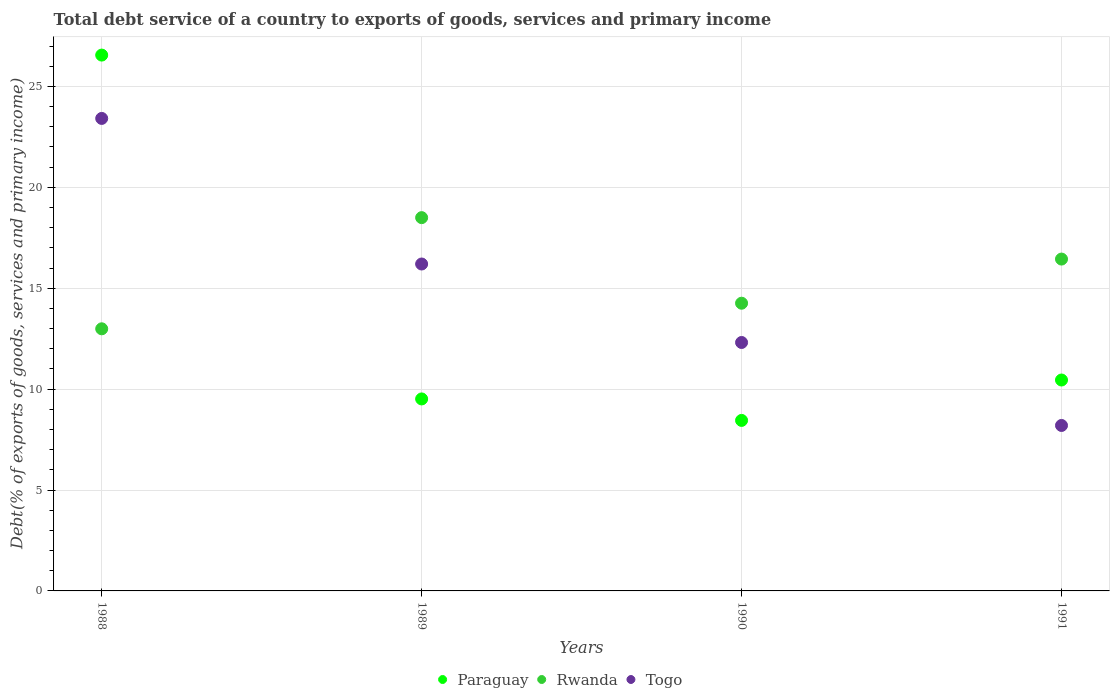How many different coloured dotlines are there?
Provide a succinct answer. 3. Is the number of dotlines equal to the number of legend labels?
Your response must be concise. Yes. What is the total debt service in Togo in 1990?
Give a very brief answer. 12.31. Across all years, what is the maximum total debt service in Togo?
Give a very brief answer. 23.42. Across all years, what is the minimum total debt service in Rwanda?
Provide a succinct answer. 12.99. What is the total total debt service in Rwanda in the graph?
Offer a very short reply. 62.19. What is the difference between the total debt service in Paraguay in 1990 and that in 1991?
Offer a very short reply. -2. What is the difference between the total debt service in Rwanda in 1991 and the total debt service in Togo in 1990?
Your answer should be compact. 4.13. What is the average total debt service in Rwanda per year?
Make the answer very short. 15.55. In the year 1988, what is the difference between the total debt service in Rwanda and total debt service in Togo?
Your answer should be very brief. -10.43. What is the ratio of the total debt service in Togo in 1988 to that in 1989?
Keep it short and to the point. 1.45. What is the difference between the highest and the second highest total debt service in Paraguay?
Make the answer very short. 16.1. What is the difference between the highest and the lowest total debt service in Paraguay?
Your answer should be very brief. 18.1. Is it the case that in every year, the sum of the total debt service in Paraguay and total debt service in Togo  is greater than the total debt service in Rwanda?
Give a very brief answer. Yes. How many dotlines are there?
Ensure brevity in your answer.  3. How many years are there in the graph?
Give a very brief answer. 4. What is the difference between two consecutive major ticks on the Y-axis?
Your answer should be compact. 5. Are the values on the major ticks of Y-axis written in scientific E-notation?
Ensure brevity in your answer.  No. How many legend labels are there?
Offer a terse response. 3. What is the title of the graph?
Give a very brief answer. Total debt service of a country to exports of goods, services and primary income. Does "OECD members" appear as one of the legend labels in the graph?
Your response must be concise. No. What is the label or title of the Y-axis?
Provide a short and direct response. Debt(% of exports of goods, services and primary income). What is the Debt(% of exports of goods, services and primary income) in Paraguay in 1988?
Give a very brief answer. 26.55. What is the Debt(% of exports of goods, services and primary income) of Rwanda in 1988?
Give a very brief answer. 12.99. What is the Debt(% of exports of goods, services and primary income) in Togo in 1988?
Offer a very short reply. 23.42. What is the Debt(% of exports of goods, services and primary income) of Paraguay in 1989?
Your answer should be very brief. 9.51. What is the Debt(% of exports of goods, services and primary income) in Rwanda in 1989?
Provide a short and direct response. 18.5. What is the Debt(% of exports of goods, services and primary income) in Togo in 1989?
Keep it short and to the point. 16.2. What is the Debt(% of exports of goods, services and primary income) of Paraguay in 1990?
Your answer should be very brief. 8.45. What is the Debt(% of exports of goods, services and primary income) of Rwanda in 1990?
Your answer should be compact. 14.26. What is the Debt(% of exports of goods, services and primary income) of Togo in 1990?
Your answer should be very brief. 12.31. What is the Debt(% of exports of goods, services and primary income) of Paraguay in 1991?
Your response must be concise. 10.45. What is the Debt(% of exports of goods, services and primary income) in Rwanda in 1991?
Provide a succinct answer. 16.45. What is the Debt(% of exports of goods, services and primary income) in Togo in 1991?
Ensure brevity in your answer.  8.2. Across all years, what is the maximum Debt(% of exports of goods, services and primary income) of Paraguay?
Provide a succinct answer. 26.55. Across all years, what is the maximum Debt(% of exports of goods, services and primary income) of Rwanda?
Provide a succinct answer. 18.5. Across all years, what is the maximum Debt(% of exports of goods, services and primary income) in Togo?
Your answer should be very brief. 23.42. Across all years, what is the minimum Debt(% of exports of goods, services and primary income) of Paraguay?
Provide a short and direct response. 8.45. Across all years, what is the minimum Debt(% of exports of goods, services and primary income) in Rwanda?
Offer a very short reply. 12.99. Across all years, what is the minimum Debt(% of exports of goods, services and primary income) in Togo?
Your answer should be compact. 8.2. What is the total Debt(% of exports of goods, services and primary income) in Paraguay in the graph?
Keep it short and to the point. 54.97. What is the total Debt(% of exports of goods, services and primary income) in Rwanda in the graph?
Offer a very short reply. 62.19. What is the total Debt(% of exports of goods, services and primary income) in Togo in the graph?
Your response must be concise. 60.13. What is the difference between the Debt(% of exports of goods, services and primary income) of Paraguay in 1988 and that in 1989?
Ensure brevity in your answer.  17.04. What is the difference between the Debt(% of exports of goods, services and primary income) of Rwanda in 1988 and that in 1989?
Your response must be concise. -5.51. What is the difference between the Debt(% of exports of goods, services and primary income) in Togo in 1988 and that in 1989?
Offer a terse response. 7.21. What is the difference between the Debt(% of exports of goods, services and primary income) of Paraguay in 1988 and that in 1990?
Your answer should be compact. 18.1. What is the difference between the Debt(% of exports of goods, services and primary income) in Rwanda in 1988 and that in 1990?
Your answer should be compact. -1.27. What is the difference between the Debt(% of exports of goods, services and primary income) of Togo in 1988 and that in 1990?
Offer a terse response. 11.1. What is the difference between the Debt(% of exports of goods, services and primary income) of Paraguay in 1988 and that in 1991?
Provide a succinct answer. 16.1. What is the difference between the Debt(% of exports of goods, services and primary income) in Rwanda in 1988 and that in 1991?
Ensure brevity in your answer.  -3.46. What is the difference between the Debt(% of exports of goods, services and primary income) of Togo in 1988 and that in 1991?
Your response must be concise. 15.22. What is the difference between the Debt(% of exports of goods, services and primary income) of Paraguay in 1989 and that in 1990?
Your answer should be very brief. 1.06. What is the difference between the Debt(% of exports of goods, services and primary income) in Rwanda in 1989 and that in 1990?
Make the answer very short. 4.24. What is the difference between the Debt(% of exports of goods, services and primary income) in Togo in 1989 and that in 1990?
Give a very brief answer. 3.89. What is the difference between the Debt(% of exports of goods, services and primary income) in Paraguay in 1989 and that in 1991?
Keep it short and to the point. -0.94. What is the difference between the Debt(% of exports of goods, services and primary income) in Rwanda in 1989 and that in 1991?
Your response must be concise. 2.05. What is the difference between the Debt(% of exports of goods, services and primary income) in Togo in 1989 and that in 1991?
Provide a succinct answer. 8. What is the difference between the Debt(% of exports of goods, services and primary income) in Paraguay in 1990 and that in 1991?
Keep it short and to the point. -2. What is the difference between the Debt(% of exports of goods, services and primary income) of Rwanda in 1990 and that in 1991?
Your answer should be very brief. -2.19. What is the difference between the Debt(% of exports of goods, services and primary income) in Togo in 1990 and that in 1991?
Make the answer very short. 4.11. What is the difference between the Debt(% of exports of goods, services and primary income) of Paraguay in 1988 and the Debt(% of exports of goods, services and primary income) of Rwanda in 1989?
Your answer should be very brief. 8.06. What is the difference between the Debt(% of exports of goods, services and primary income) in Paraguay in 1988 and the Debt(% of exports of goods, services and primary income) in Togo in 1989?
Your response must be concise. 10.35. What is the difference between the Debt(% of exports of goods, services and primary income) in Rwanda in 1988 and the Debt(% of exports of goods, services and primary income) in Togo in 1989?
Your response must be concise. -3.21. What is the difference between the Debt(% of exports of goods, services and primary income) of Paraguay in 1988 and the Debt(% of exports of goods, services and primary income) of Rwanda in 1990?
Your answer should be compact. 12.3. What is the difference between the Debt(% of exports of goods, services and primary income) in Paraguay in 1988 and the Debt(% of exports of goods, services and primary income) in Togo in 1990?
Provide a short and direct response. 14.24. What is the difference between the Debt(% of exports of goods, services and primary income) in Rwanda in 1988 and the Debt(% of exports of goods, services and primary income) in Togo in 1990?
Provide a short and direct response. 0.68. What is the difference between the Debt(% of exports of goods, services and primary income) of Paraguay in 1988 and the Debt(% of exports of goods, services and primary income) of Rwanda in 1991?
Give a very brief answer. 10.11. What is the difference between the Debt(% of exports of goods, services and primary income) in Paraguay in 1988 and the Debt(% of exports of goods, services and primary income) in Togo in 1991?
Offer a terse response. 18.35. What is the difference between the Debt(% of exports of goods, services and primary income) of Rwanda in 1988 and the Debt(% of exports of goods, services and primary income) of Togo in 1991?
Ensure brevity in your answer.  4.79. What is the difference between the Debt(% of exports of goods, services and primary income) of Paraguay in 1989 and the Debt(% of exports of goods, services and primary income) of Rwanda in 1990?
Keep it short and to the point. -4.74. What is the difference between the Debt(% of exports of goods, services and primary income) of Paraguay in 1989 and the Debt(% of exports of goods, services and primary income) of Togo in 1990?
Provide a succinct answer. -2.8. What is the difference between the Debt(% of exports of goods, services and primary income) of Rwanda in 1989 and the Debt(% of exports of goods, services and primary income) of Togo in 1990?
Make the answer very short. 6.19. What is the difference between the Debt(% of exports of goods, services and primary income) of Paraguay in 1989 and the Debt(% of exports of goods, services and primary income) of Rwanda in 1991?
Give a very brief answer. -6.93. What is the difference between the Debt(% of exports of goods, services and primary income) of Paraguay in 1989 and the Debt(% of exports of goods, services and primary income) of Togo in 1991?
Keep it short and to the point. 1.31. What is the difference between the Debt(% of exports of goods, services and primary income) of Rwanda in 1989 and the Debt(% of exports of goods, services and primary income) of Togo in 1991?
Ensure brevity in your answer.  10.3. What is the difference between the Debt(% of exports of goods, services and primary income) in Paraguay in 1990 and the Debt(% of exports of goods, services and primary income) in Rwanda in 1991?
Give a very brief answer. -8. What is the difference between the Debt(% of exports of goods, services and primary income) in Paraguay in 1990 and the Debt(% of exports of goods, services and primary income) in Togo in 1991?
Offer a terse response. 0.25. What is the difference between the Debt(% of exports of goods, services and primary income) in Rwanda in 1990 and the Debt(% of exports of goods, services and primary income) in Togo in 1991?
Give a very brief answer. 6.06. What is the average Debt(% of exports of goods, services and primary income) in Paraguay per year?
Provide a succinct answer. 13.74. What is the average Debt(% of exports of goods, services and primary income) in Rwanda per year?
Provide a short and direct response. 15.55. What is the average Debt(% of exports of goods, services and primary income) of Togo per year?
Offer a terse response. 15.03. In the year 1988, what is the difference between the Debt(% of exports of goods, services and primary income) of Paraguay and Debt(% of exports of goods, services and primary income) of Rwanda?
Make the answer very short. 13.56. In the year 1988, what is the difference between the Debt(% of exports of goods, services and primary income) of Paraguay and Debt(% of exports of goods, services and primary income) of Togo?
Make the answer very short. 3.14. In the year 1988, what is the difference between the Debt(% of exports of goods, services and primary income) of Rwanda and Debt(% of exports of goods, services and primary income) of Togo?
Ensure brevity in your answer.  -10.43. In the year 1989, what is the difference between the Debt(% of exports of goods, services and primary income) of Paraguay and Debt(% of exports of goods, services and primary income) of Rwanda?
Offer a terse response. -8.98. In the year 1989, what is the difference between the Debt(% of exports of goods, services and primary income) of Paraguay and Debt(% of exports of goods, services and primary income) of Togo?
Offer a terse response. -6.69. In the year 1989, what is the difference between the Debt(% of exports of goods, services and primary income) in Rwanda and Debt(% of exports of goods, services and primary income) in Togo?
Ensure brevity in your answer.  2.3. In the year 1990, what is the difference between the Debt(% of exports of goods, services and primary income) of Paraguay and Debt(% of exports of goods, services and primary income) of Rwanda?
Ensure brevity in your answer.  -5.81. In the year 1990, what is the difference between the Debt(% of exports of goods, services and primary income) in Paraguay and Debt(% of exports of goods, services and primary income) in Togo?
Give a very brief answer. -3.86. In the year 1990, what is the difference between the Debt(% of exports of goods, services and primary income) of Rwanda and Debt(% of exports of goods, services and primary income) of Togo?
Your answer should be compact. 1.95. In the year 1991, what is the difference between the Debt(% of exports of goods, services and primary income) of Paraguay and Debt(% of exports of goods, services and primary income) of Rwanda?
Make the answer very short. -5.99. In the year 1991, what is the difference between the Debt(% of exports of goods, services and primary income) in Paraguay and Debt(% of exports of goods, services and primary income) in Togo?
Provide a succinct answer. 2.25. In the year 1991, what is the difference between the Debt(% of exports of goods, services and primary income) of Rwanda and Debt(% of exports of goods, services and primary income) of Togo?
Your answer should be compact. 8.25. What is the ratio of the Debt(% of exports of goods, services and primary income) of Paraguay in 1988 to that in 1989?
Keep it short and to the point. 2.79. What is the ratio of the Debt(% of exports of goods, services and primary income) in Rwanda in 1988 to that in 1989?
Ensure brevity in your answer.  0.7. What is the ratio of the Debt(% of exports of goods, services and primary income) in Togo in 1988 to that in 1989?
Ensure brevity in your answer.  1.45. What is the ratio of the Debt(% of exports of goods, services and primary income) of Paraguay in 1988 to that in 1990?
Ensure brevity in your answer.  3.14. What is the ratio of the Debt(% of exports of goods, services and primary income) of Rwanda in 1988 to that in 1990?
Provide a short and direct response. 0.91. What is the ratio of the Debt(% of exports of goods, services and primary income) in Togo in 1988 to that in 1990?
Make the answer very short. 1.9. What is the ratio of the Debt(% of exports of goods, services and primary income) of Paraguay in 1988 to that in 1991?
Give a very brief answer. 2.54. What is the ratio of the Debt(% of exports of goods, services and primary income) of Rwanda in 1988 to that in 1991?
Offer a terse response. 0.79. What is the ratio of the Debt(% of exports of goods, services and primary income) in Togo in 1988 to that in 1991?
Provide a succinct answer. 2.86. What is the ratio of the Debt(% of exports of goods, services and primary income) of Paraguay in 1989 to that in 1990?
Offer a terse response. 1.13. What is the ratio of the Debt(% of exports of goods, services and primary income) in Rwanda in 1989 to that in 1990?
Provide a succinct answer. 1.3. What is the ratio of the Debt(% of exports of goods, services and primary income) in Togo in 1989 to that in 1990?
Offer a very short reply. 1.32. What is the ratio of the Debt(% of exports of goods, services and primary income) of Paraguay in 1989 to that in 1991?
Offer a terse response. 0.91. What is the ratio of the Debt(% of exports of goods, services and primary income) in Rwanda in 1989 to that in 1991?
Keep it short and to the point. 1.12. What is the ratio of the Debt(% of exports of goods, services and primary income) in Togo in 1989 to that in 1991?
Give a very brief answer. 1.98. What is the ratio of the Debt(% of exports of goods, services and primary income) in Paraguay in 1990 to that in 1991?
Offer a terse response. 0.81. What is the ratio of the Debt(% of exports of goods, services and primary income) of Rwanda in 1990 to that in 1991?
Offer a terse response. 0.87. What is the ratio of the Debt(% of exports of goods, services and primary income) of Togo in 1990 to that in 1991?
Your response must be concise. 1.5. What is the difference between the highest and the second highest Debt(% of exports of goods, services and primary income) of Paraguay?
Provide a succinct answer. 16.1. What is the difference between the highest and the second highest Debt(% of exports of goods, services and primary income) of Rwanda?
Your answer should be compact. 2.05. What is the difference between the highest and the second highest Debt(% of exports of goods, services and primary income) in Togo?
Make the answer very short. 7.21. What is the difference between the highest and the lowest Debt(% of exports of goods, services and primary income) of Paraguay?
Provide a short and direct response. 18.1. What is the difference between the highest and the lowest Debt(% of exports of goods, services and primary income) in Rwanda?
Your response must be concise. 5.51. What is the difference between the highest and the lowest Debt(% of exports of goods, services and primary income) in Togo?
Offer a terse response. 15.22. 